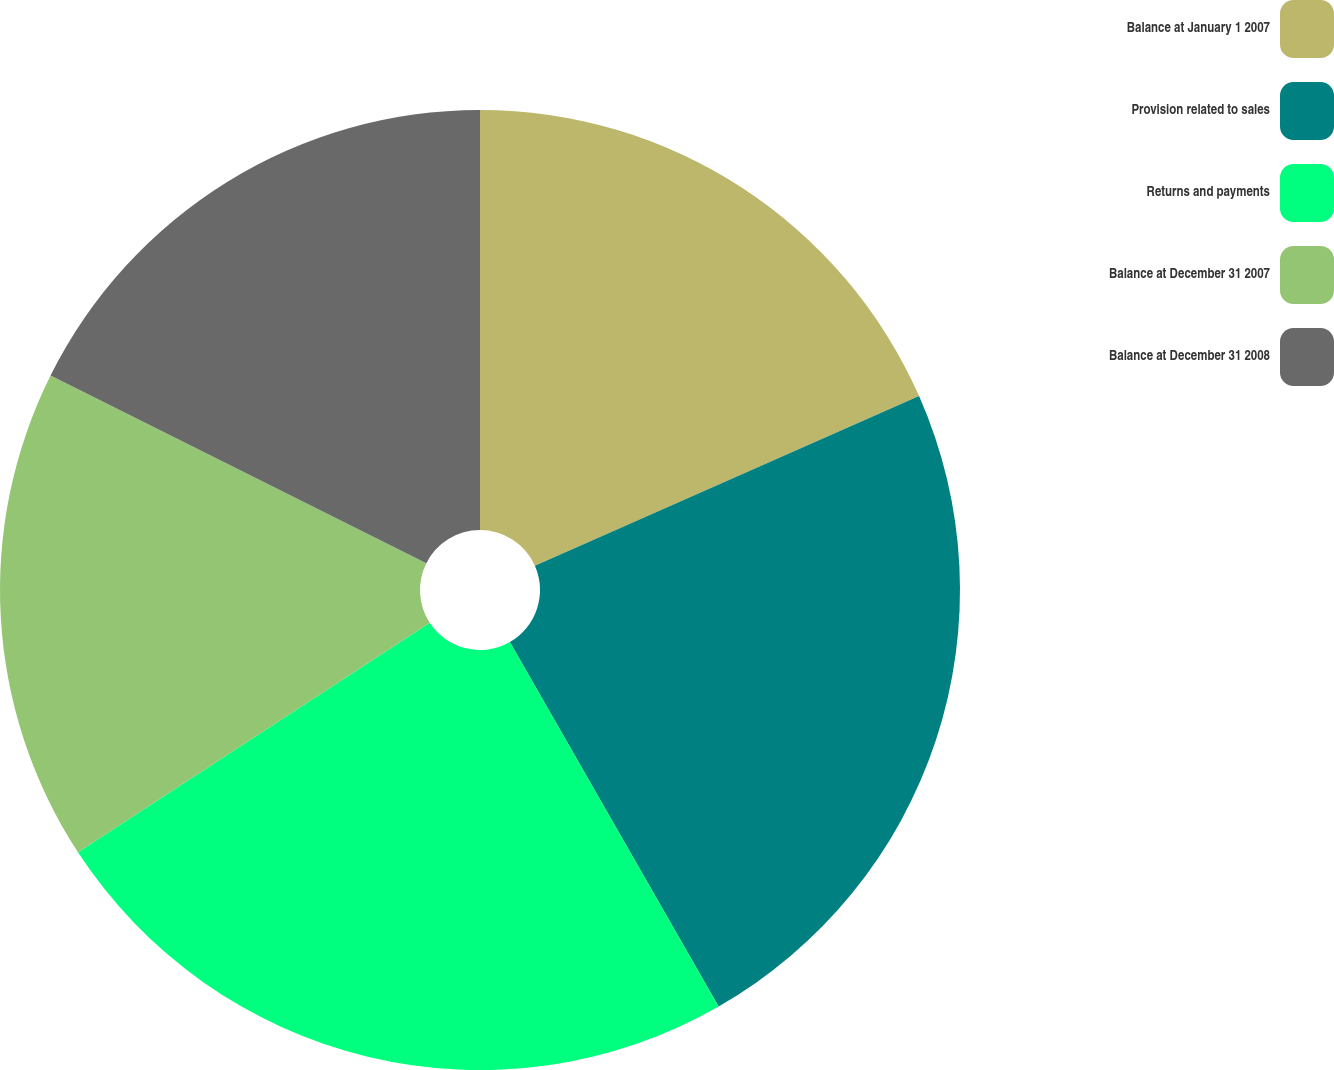Convert chart to OTSL. <chart><loc_0><loc_0><loc_500><loc_500><pie_chart><fcel>Balance at January 1 2007<fcel>Provision related to sales<fcel>Returns and payments<fcel>Balance at December 31 2007<fcel>Balance at December 31 2008<nl><fcel>18.38%<fcel>23.34%<fcel>24.08%<fcel>16.57%<fcel>17.63%<nl></chart> 